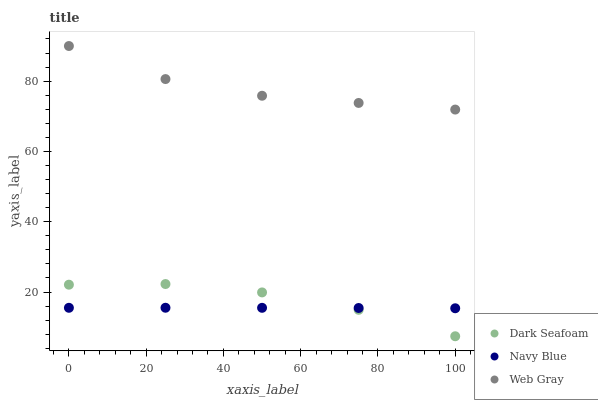Does Navy Blue have the minimum area under the curve?
Answer yes or no. Yes. Does Web Gray have the maximum area under the curve?
Answer yes or no. Yes. Does Dark Seafoam have the minimum area under the curve?
Answer yes or no. No. Does Dark Seafoam have the maximum area under the curve?
Answer yes or no. No. Is Navy Blue the smoothest?
Answer yes or no. Yes. Is Dark Seafoam the roughest?
Answer yes or no. Yes. Is Web Gray the smoothest?
Answer yes or no. No. Is Web Gray the roughest?
Answer yes or no. No. Does Dark Seafoam have the lowest value?
Answer yes or no. Yes. Does Web Gray have the lowest value?
Answer yes or no. No. Does Web Gray have the highest value?
Answer yes or no. Yes. Does Dark Seafoam have the highest value?
Answer yes or no. No. Is Dark Seafoam less than Web Gray?
Answer yes or no. Yes. Is Web Gray greater than Navy Blue?
Answer yes or no. Yes. Does Navy Blue intersect Dark Seafoam?
Answer yes or no. Yes. Is Navy Blue less than Dark Seafoam?
Answer yes or no. No. Is Navy Blue greater than Dark Seafoam?
Answer yes or no. No. Does Dark Seafoam intersect Web Gray?
Answer yes or no. No. 